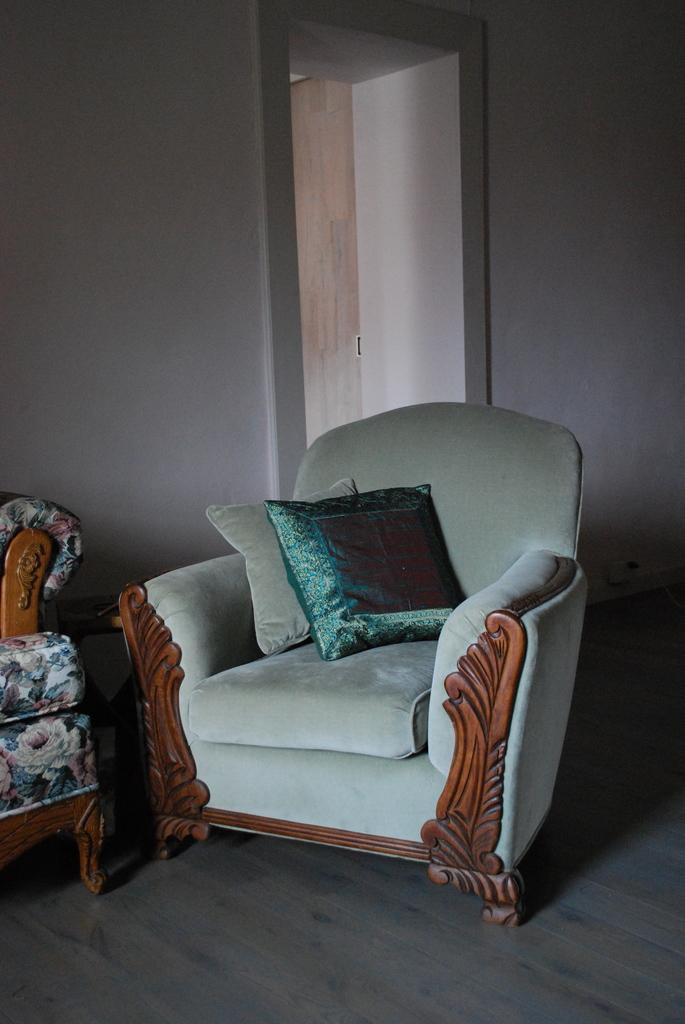Please provide a concise description of this image. This is the picture of a room where there are two chairs among them one is in green color. There are two pillows in one chair beside there is a table. We can also see a wall and the floor. 